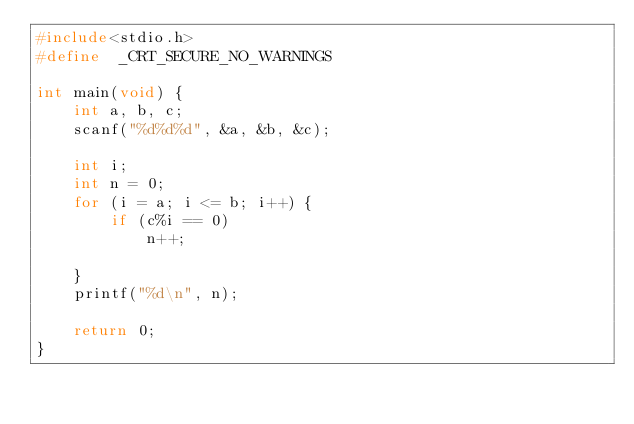<code> <loc_0><loc_0><loc_500><loc_500><_C_>#include<stdio.h>
#define  _CRT_SECURE_NO_WARNINGS

int main(void) {
	int a, b, c;
	scanf("%d%d%d", &a, &b, &c);

	int i;
	int n = 0;
	for (i = a; i <= b; i++) {
		if (c%i == 0)
			n++;

	}
	printf("%d\n", n);

	return 0;
}</code> 